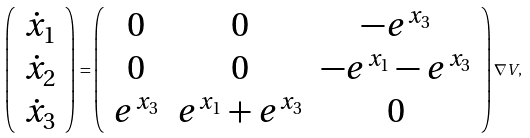<formula> <loc_0><loc_0><loc_500><loc_500>\left ( \begin{array} { c } \dot { x } _ { 1 } \\ \dot { x } _ { 2 } \\ \dot { x } _ { 3 } \end{array} \right ) = \left ( \begin{array} { c c c } 0 & 0 & - e ^ { x _ { 3 } } \\ 0 & 0 & - e ^ { x _ { 1 } } - e ^ { x _ { 3 } } \\ e ^ { x _ { 3 } } & e ^ { x _ { 1 } } + e ^ { x _ { 3 } } & 0 \end{array} \right ) \nabla V ,</formula> 